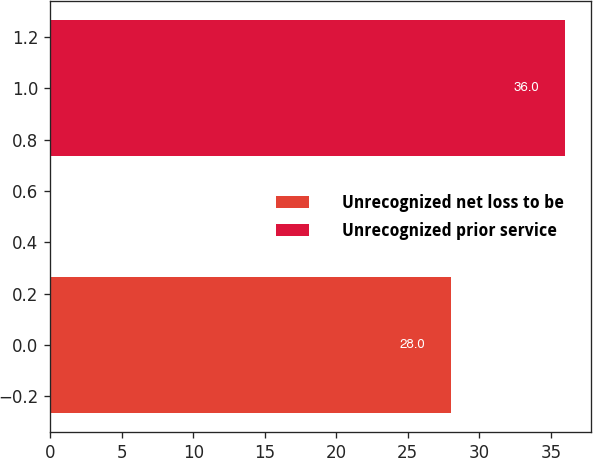Convert chart to OTSL. <chart><loc_0><loc_0><loc_500><loc_500><bar_chart><fcel>Unrecognized net loss to be<fcel>Unrecognized prior service<nl><fcel>28<fcel>36<nl></chart> 